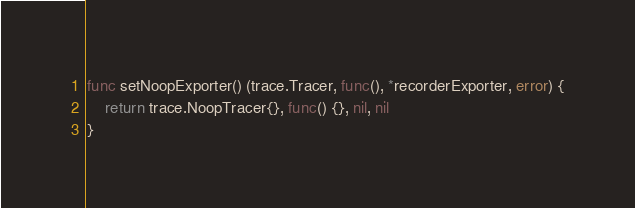<code> <loc_0><loc_0><loc_500><loc_500><_Go_>
func setNoopExporter() (trace.Tracer, func(), *recorderExporter, error) {
	return trace.NoopTracer{}, func() {}, nil, nil
}
</code> 